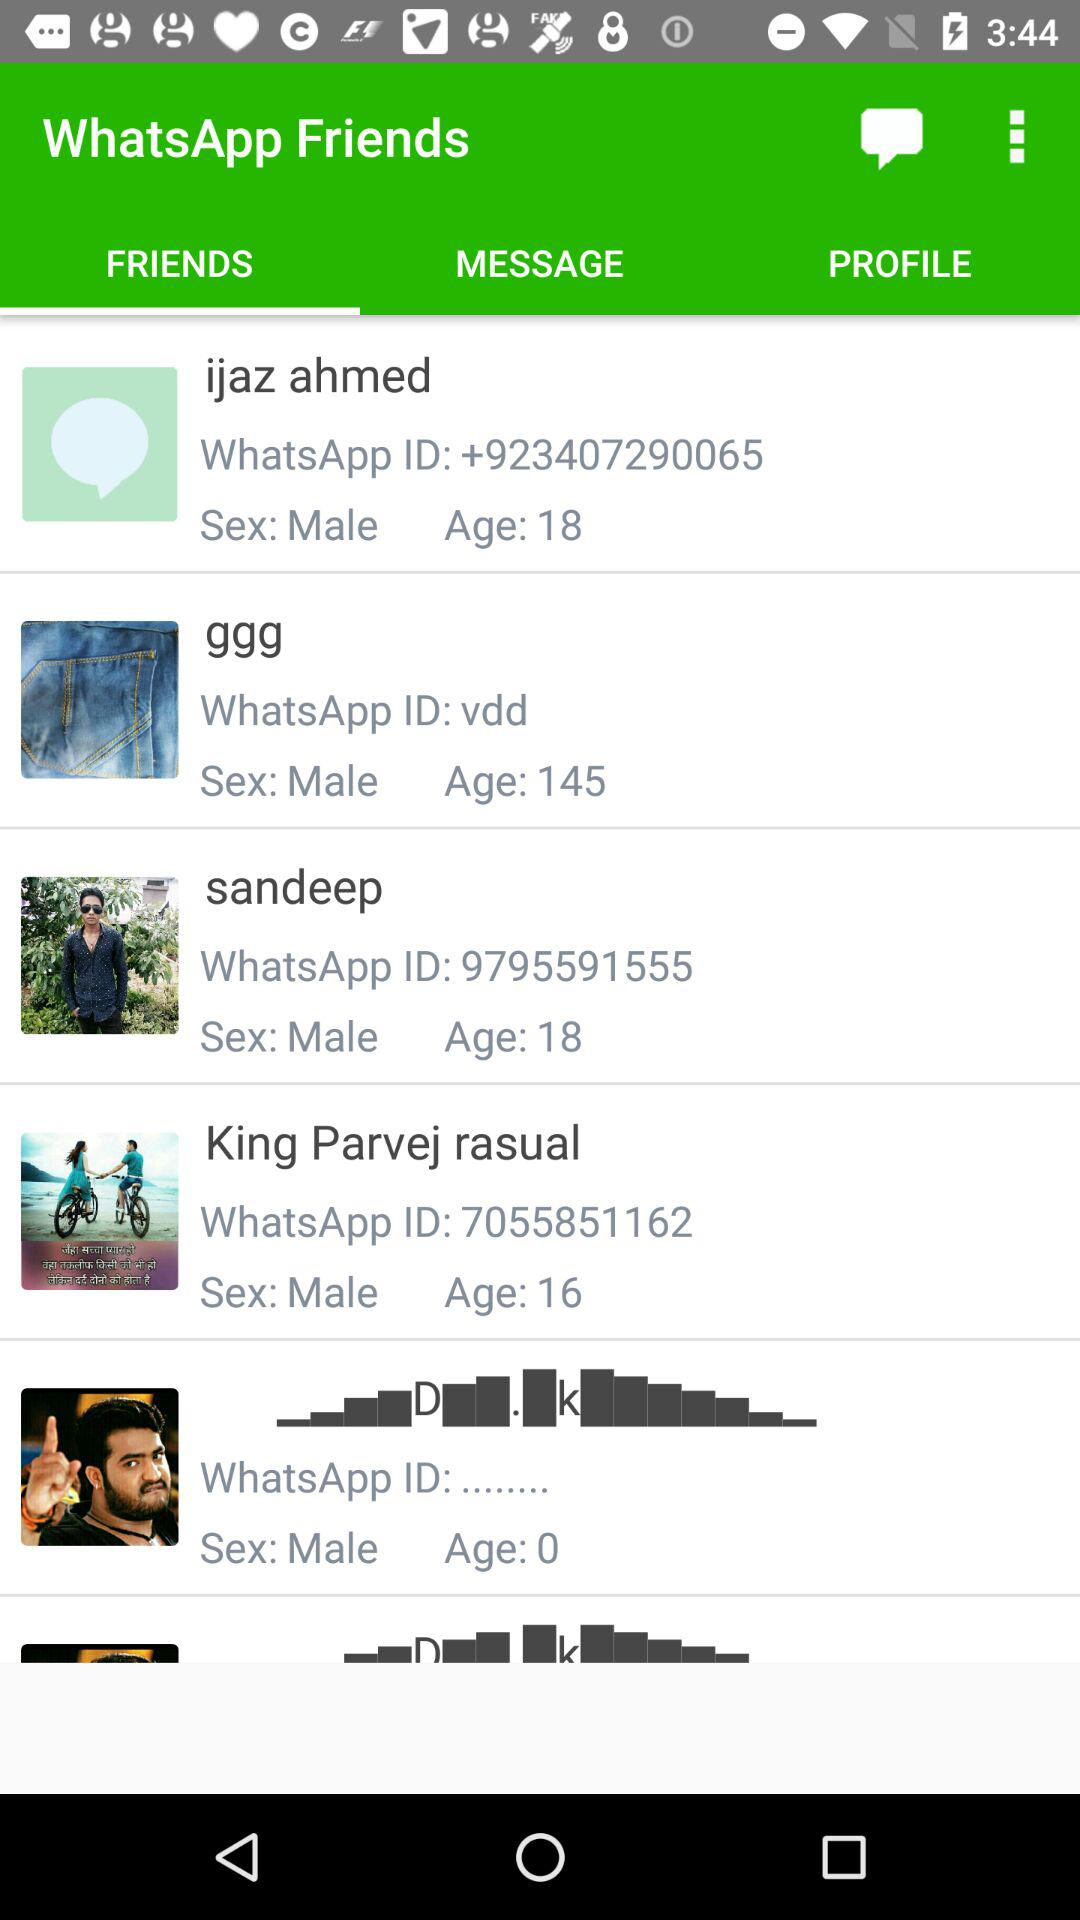What is the gender of Ijaz Ahmed? The gender is male. 